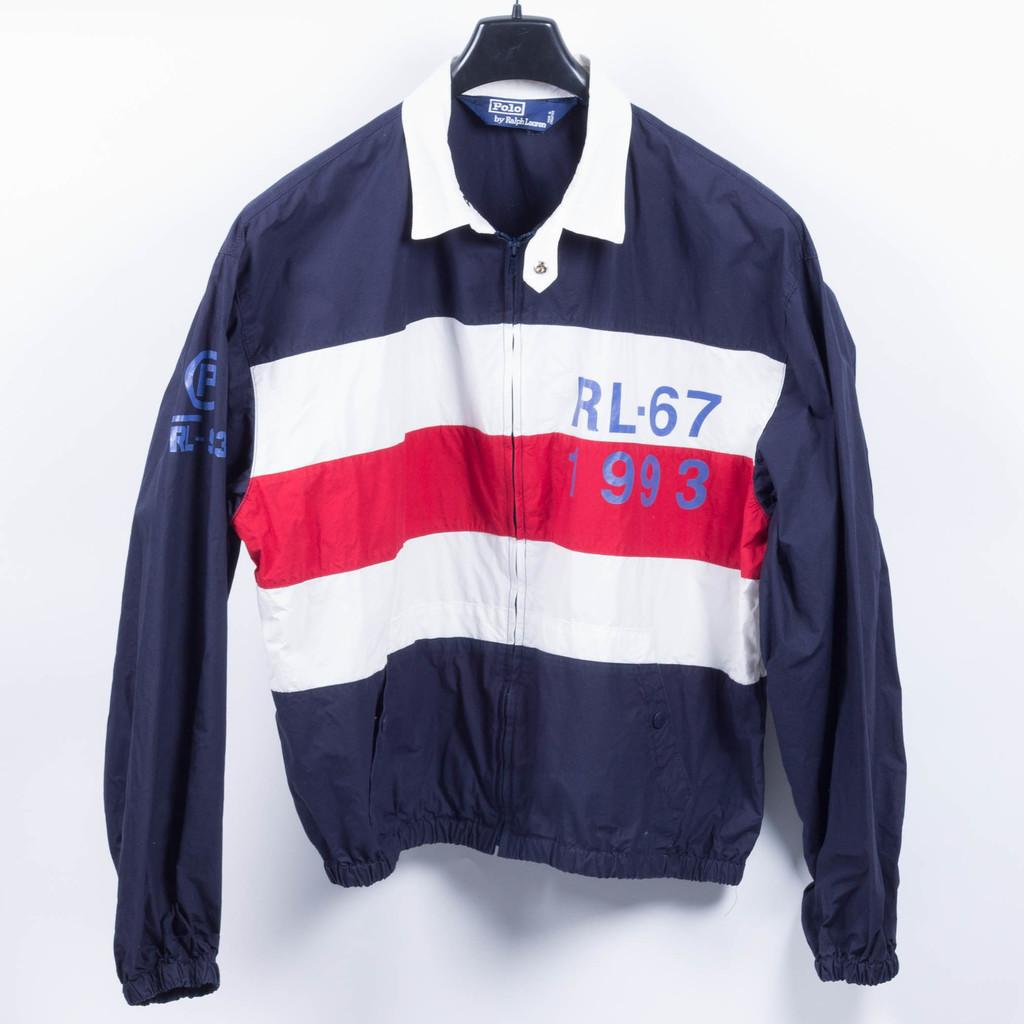<image>
Give a short and clear explanation of the subsequent image. A long sleeve polo sits on display with RL-67 993 is on the right side looking at it. 